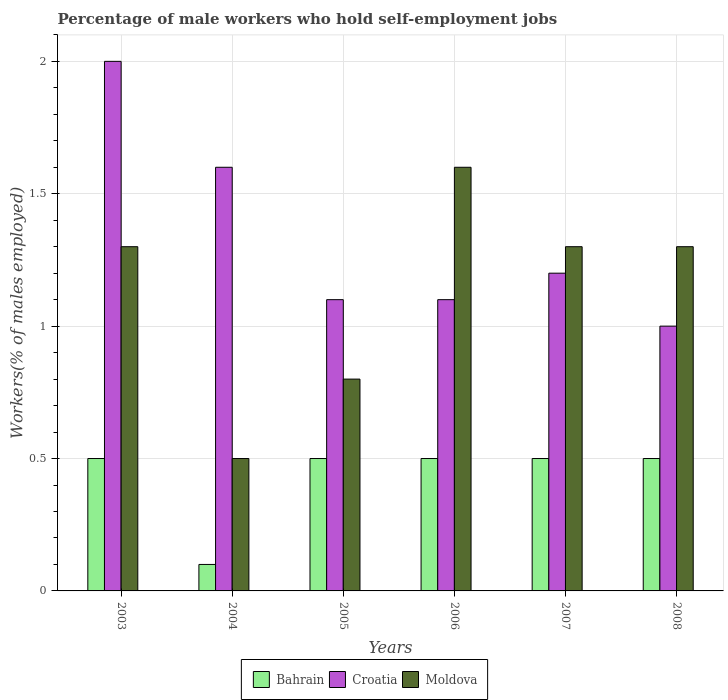How many different coloured bars are there?
Offer a very short reply. 3. How many groups of bars are there?
Offer a very short reply. 6. What is the label of the 4th group of bars from the left?
Your answer should be compact. 2006. In how many cases, is the number of bars for a given year not equal to the number of legend labels?
Keep it short and to the point. 0. What is the percentage of self-employed male workers in Croatia in 2004?
Keep it short and to the point. 1.6. Across all years, what is the maximum percentage of self-employed male workers in Moldova?
Your response must be concise. 1.6. In which year was the percentage of self-employed male workers in Bahrain maximum?
Your response must be concise. 2003. In which year was the percentage of self-employed male workers in Croatia minimum?
Make the answer very short. 2008. What is the total percentage of self-employed male workers in Moldova in the graph?
Offer a terse response. 6.8. What is the difference between the percentage of self-employed male workers in Bahrain in 2007 and the percentage of self-employed male workers in Croatia in 2006?
Provide a short and direct response. -0.6. What is the average percentage of self-employed male workers in Bahrain per year?
Provide a short and direct response. 0.43. In the year 2007, what is the difference between the percentage of self-employed male workers in Croatia and percentage of self-employed male workers in Moldova?
Your response must be concise. -0.1. In how many years, is the percentage of self-employed male workers in Bahrain greater than 0.1 %?
Give a very brief answer. 6. What is the ratio of the percentage of self-employed male workers in Moldova in 2004 to that in 2007?
Your answer should be very brief. 0.38. Is the percentage of self-employed male workers in Moldova in 2005 less than that in 2008?
Provide a succinct answer. Yes. Is the difference between the percentage of self-employed male workers in Croatia in 2004 and 2006 greater than the difference between the percentage of self-employed male workers in Moldova in 2004 and 2006?
Keep it short and to the point. Yes. What is the difference between the highest and the second highest percentage of self-employed male workers in Croatia?
Your answer should be very brief. 0.4. Is the sum of the percentage of self-employed male workers in Croatia in 2006 and 2007 greater than the maximum percentage of self-employed male workers in Moldova across all years?
Give a very brief answer. Yes. What does the 1st bar from the left in 2004 represents?
Your answer should be compact. Bahrain. What does the 1st bar from the right in 2008 represents?
Offer a terse response. Moldova. Is it the case that in every year, the sum of the percentage of self-employed male workers in Croatia and percentage of self-employed male workers in Bahrain is greater than the percentage of self-employed male workers in Moldova?
Ensure brevity in your answer.  No. How many years are there in the graph?
Provide a succinct answer. 6. Are the values on the major ticks of Y-axis written in scientific E-notation?
Ensure brevity in your answer.  No. Does the graph contain grids?
Provide a short and direct response. Yes. What is the title of the graph?
Your answer should be very brief. Percentage of male workers who hold self-employment jobs. Does "Sub-Saharan Africa (all income levels)" appear as one of the legend labels in the graph?
Your answer should be very brief. No. What is the label or title of the X-axis?
Offer a terse response. Years. What is the label or title of the Y-axis?
Your answer should be compact. Workers(% of males employed). What is the Workers(% of males employed) in Bahrain in 2003?
Offer a very short reply. 0.5. What is the Workers(% of males employed) in Croatia in 2003?
Keep it short and to the point. 2. What is the Workers(% of males employed) of Moldova in 2003?
Provide a succinct answer. 1.3. What is the Workers(% of males employed) of Bahrain in 2004?
Provide a short and direct response. 0.1. What is the Workers(% of males employed) of Croatia in 2004?
Ensure brevity in your answer.  1.6. What is the Workers(% of males employed) of Moldova in 2004?
Ensure brevity in your answer.  0.5. What is the Workers(% of males employed) in Bahrain in 2005?
Make the answer very short. 0.5. What is the Workers(% of males employed) of Croatia in 2005?
Provide a short and direct response. 1.1. What is the Workers(% of males employed) of Moldova in 2005?
Provide a succinct answer. 0.8. What is the Workers(% of males employed) of Croatia in 2006?
Your answer should be very brief. 1.1. What is the Workers(% of males employed) of Moldova in 2006?
Ensure brevity in your answer.  1.6. What is the Workers(% of males employed) of Bahrain in 2007?
Your answer should be very brief. 0.5. What is the Workers(% of males employed) in Croatia in 2007?
Provide a short and direct response. 1.2. What is the Workers(% of males employed) of Moldova in 2007?
Your answer should be compact. 1.3. What is the Workers(% of males employed) of Moldova in 2008?
Give a very brief answer. 1.3. Across all years, what is the maximum Workers(% of males employed) in Bahrain?
Your response must be concise. 0.5. Across all years, what is the maximum Workers(% of males employed) in Moldova?
Your response must be concise. 1.6. Across all years, what is the minimum Workers(% of males employed) in Bahrain?
Make the answer very short. 0.1. What is the total Workers(% of males employed) of Moldova in the graph?
Provide a short and direct response. 6.8. What is the difference between the Workers(% of males employed) in Croatia in 2003 and that in 2004?
Your answer should be very brief. 0.4. What is the difference between the Workers(% of males employed) in Moldova in 2003 and that in 2004?
Ensure brevity in your answer.  0.8. What is the difference between the Workers(% of males employed) in Bahrain in 2003 and that in 2005?
Keep it short and to the point. 0. What is the difference between the Workers(% of males employed) in Croatia in 2003 and that in 2005?
Your answer should be very brief. 0.9. What is the difference between the Workers(% of males employed) in Moldova in 2003 and that in 2005?
Your answer should be very brief. 0.5. What is the difference between the Workers(% of males employed) of Bahrain in 2003 and that in 2006?
Provide a succinct answer. 0. What is the difference between the Workers(% of males employed) in Bahrain in 2003 and that in 2007?
Provide a succinct answer. 0. What is the difference between the Workers(% of males employed) in Croatia in 2003 and that in 2007?
Make the answer very short. 0.8. What is the difference between the Workers(% of males employed) in Moldova in 2003 and that in 2007?
Your answer should be very brief. 0. What is the difference between the Workers(% of males employed) of Bahrain in 2003 and that in 2008?
Provide a succinct answer. 0. What is the difference between the Workers(% of males employed) of Bahrain in 2004 and that in 2005?
Your answer should be very brief. -0.4. What is the difference between the Workers(% of males employed) of Bahrain in 2004 and that in 2007?
Ensure brevity in your answer.  -0.4. What is the difference between the Workers(% of males employed) in Bahrain in 2004 and that in 2008?
Provide a short and direct response. -0.4. What is the difference between the Workers(% of males employed) in Moldova in 2004 and that in 2008?
Your answer should be compact. -0.8. What is the difference between the Workers(% of males employed) in Bahrain in 2005 and that in 2007?
Your response must be concise. 0. What is the difference between the Workers(% of males employed) of Bahrain in 2005 and that in 2008?
Your response must be concise. 0. What is the difference between the Workers(% of males employed) in Croatia in 2005 and that in 2008?
Your response must be concise. 0.1. What is the difference between the Workers(% of males employed) in Moldova in 2005 and that in 2008?
Offer a terse response. -0.5. What is the difference between the Workers(% of males employed) in Bahrain in 2006 and that in 2007?
Offer a terse response. 0. What is the difference between the Workers(% of males employed) in Croatia in 2006 and that in 2007?
Offer a terse response. -0.1. What is the difference between the Workers(% of males employed) of Bahrain in 2006 and that in 2008?
Make the answer very short. 0. What is the difference between the Workers(% of males employed) in Croatia in 2006 and that in 2008?
Give a very brief answer. 0.1. What is the difference between the Workers(% of males employed) in Bahrain in 2007 and that in 2008?
Keep it short and to the point. 0. What is the difference between the Workers(% of males employed) in Croatia in 2007 and that in 2008?
Keep it short and to the point. 0.2. What is the difference between the Workers(% of males employed) in Bahrain in 2003 and the Workers(% of males employed) in Moldova in 2004?
Your answer should be very brief. 0. What is the difference between the Workers(% of males employed) of Croatia in 2003 and the Workers(% of males employed) of Moldova in 2004?
Provide a succinct answer. 1.5. What is the difference between the Workers(% of males employed) of Bahrain in 2003 and the Workers(% of males employed) of Moldova in 2006?
Your answer should be very brief. -1.1. What is the difference between the Workers(% of males employed) of Croatia in 2003 and the Workers(% of males employed) of Moldova in 2006?
Provide a succinct answer. 0.4. What is the difference between the Workers(% of males employed) in Bahrain in 2003 and the Workers(% of males employed) in Moldova in 2007?
Your answer should be compact. -0.8. What is the difference between the Workers(% of males employed) of Bahrain in 2003 and the Workers(% of males employed) of Moldova in 2008?
Provide a short and direct response. -0.8. What is the difference between the Workers(% of males employed) in Croatia in 2003 and the Workers(% of males employed) in Moldova in 2008?
Offer a very short reply. 0.7. What is the difference between the Workers(% of males employed) of Bahrain in 2004 and the Workers(% of males employed) of Croatia in 2005?
Offer a terse response. -1. What is the difference between the Workers(% of males employed) of Croatia in 2004 and the Workers(% of males employed) of Moldova in 2005?
Your answer should be very brief. 0.8. What is the difference between the Workers(% of males employed) in Bahrain in 2004 and the Workers(% of males employed) in Croatia in 2006?
Offer a very short reply. -1. What is the difference between the Workers(% of males employed) of Croatia in 2004 and the Workers(% of males employed) of Moldova in 2006?
Give a very brief answer. 0. What is the difference between the Workers(% of males employed) in Bahrain in 2004 and the Workers(% of males employed) in Croatia in 2007?
Your response must be concise. -1.1. What is the difference between the Workers(% of males employed) of Croatia in 2005 and the Workers(% of males employed) of Moldova in 2006?
Your response must be concise. -0.5. What is the difference between the Workers(% of males employed) of Bahrain in 2005 and the Workers(% of males employed) of Croatia in 2007?
Provide a short and direct response. -0.7. What is the difference between the Workers(% of males employed) of Croatia in 2005 and the Workers(% of males employed) of Moldova in 2007?
Offer a terse response. -0.2. What is the difference between the Workers(% of males employed) of Bahrain in 2005 and the Workers(% of males employed) of Moldova in 2008?
Your answer should be very brief. -0.8. What is the difference between the Workers(% of males employed) in Croatia in 2005 and the Workers(% of males employed) in Moldova in 2008?
Offer a very short reply. -0.2. What is the difference between the Workers(% of males employed) of Bahrain in 2006 and the Workers(% of males employed) of Moldova in 2007?
Give a very brief answer. -0.8. What is the difference between the Workers(% of males employed) of Croatia in 2006 and the Workers(% of males employed) of Moldova in 2007?
Give a very brief answer. -0.2. What is the difference between the Workers(% of males employed) in Bahrain in 2006 and the Workers(% of males employed) in Moldova in 2008?
Your answer should be very brief. -0.8. What is the difference between the Workers(% of males employed) of Bahrain in 2007 and the Workers(% of males employed) of Moldova in 2008?
Ensure brevity in your answer.  -0.8. What is the difference between the Workers(% of males employed) of Croatia in 2007 and the Workers(% of males employed) of Moldova in 2008?
Provide a succinct answer. -0.1. What is the average Workers(% of males employed) of Bahrain per year?
Give a very brief answer. 0.43. What is the average Workers(% of males employed) in Croatia per year?
Offer a terse response. 1.33. What is the average Workers(% of males employed) of Moldova per year?
Ensure brevity in your answer.  1.13. In the year 2003, what is the difference between the Workers(% of males employed) in Bahrain and Workers(% of males employed) in Moldova?
Provide a succinct answer. -0.8. In the year 2003, what is the difference between the Workers(% of males employed) of Croatia and Workers(% of males employed) of Moldova?
Your answer should be very brief. 0.7. In the year 2004, what is the difference between the Workers(% of males employed) in Bahrain and Workers(% of males employed) in Moldova?
Offer a terse response. -0.4. In the year 2004, what is the difference between the Workers(% of males employed) of Croatia and Workers(% of males employed) of Moldova?
Your answer should be compact. 1.1. In the year 2005, what is the difference between the Workers(% of males employed) of Bahrain and Workers(% of males employed) of Croatia?
Your answer should be compact. -0.6. In the year 2005, what is the difference between the Workers(% of males employed) in Croatia and Workers(% of males employed) in Moldova?
Your answer should be very brief. 0.3. In the year 2006, what is the difference between the Workers(% of males employed) in Bahrain and Workers(% of males employed) in Croatia?
Offer a terse response. -0.6. In the year 2006, what is the difference between the Workers(% of males employed) in Bahrain and Workers(% of males employed) in Moldova?
Ensure brevity in your answer.  -1.1. In the year 2007, what is the difference between the Workers(% of males employed) in Croatia and Workers(% of males employed) in Moldova?
Offer a very short reply. -0.1. In the year 2008, what is the difference between the Workers(% of males employed) of Bahrain and Workers(% of males employed) of Croatia?
Your answer should be very brief. -0.5. What is the ratio of the Workers(% of males employed) of Bahrain in 2003 to that in 2004?
Keep it short and to the point. 5. What is the ratio of the Workers(% of males employed) of Bahrain in 2003 to that in 2005?
Provide a short and direct response. 1. What is the ratio of the Workers(% of males employed) of Croatia in 2003 to that in 2005?
Give a very brief answer. 1.82. What is the ratio of the Workers(% of males employed) in Moldova in 2003 to that in 2005?
Provide a succinct answer. 1.62. What is the ratio of the Workers(% of males employed) of Croatia in 2003 to that in 2006?
Make the answer very short. 1.82. What is the ratio of the Workers(% of males employed) in Moldova in 2003 to that in 2006?
Provide a succinct answer. 0.81. What is the ratio of the Workers(% of males employed) in Bahrain in 2003 to that in 2007?
Offer a very short reply. 1. What is the ratio of the Workers(% of males employed) of Croatia in 2003 to that in 2007?
Ensure brevity in your answer.  1.67. What is the ratio of the Workers(% of males employed) in Moldova in 2003 to that in 2008?
Give a very brief answer. 1. What is the ratio of the Workers(% of males employed) of Croatia in 2004 to that in 2005?
Offer a very short reply. 1.45. What is the ratio of the Workers(% of males employed) of Moldova in 2004 to that in 2005?
Make the answer very short. 0.62. What is the ratio of the Workers(% of males employed) of Bahrain in 2004 to that in 2006?
Your answer should be compact. 0.2. What is the ratio of the Workers(% of males employed) in Croatia in 2004 to that in 2006?
Provide a succinct answer. 1.45. What is the ratio of the Workers(% of males employed) of Moldova in 2004 to that in 2006?
Your response must be concise. 0.31. What is the ratio of the Workers(% of males employed) of Bahrain in 2004 to that in 2007?
Offer a very short reply. 0.2. What is the ratio of the Workers(% of males employed) of Moldova in 2004 to that in 2007?
Your answer should be compact. 0.38. What is the ratio of the Workers(% of males employed) of Croatia in 2004 to that in 2008?
Provide a short and direct response. 1.6. What is the ratio of the Workers(% of males employed) of Moldova in 2004 to that in 2008?
Give a very brief answer. 0.38. What is the ratio of the Workers(% of males employed) of Croatia in 2005 to that in 2006?
Ensure brevity in your answer.  1. What is the ratio of the Workers(% of males employed) of Moldova in 2005 to that in 2007?
Keep it short and to the point. 0.62. What is the ratio of the Workers(% of males employed) in Bahrain in 2005 to that in 2008?
Give a very brief answer. 1. What is the ratio of the Workers(% of males employed) of Croatia in 2005 to that in 2008?
Give a very brief answer. 1.1. What is the ratio of the Workers(% of males employed) of Moldova in 2005 to that in 2008?
Your response must be concise. 0.62. What is the ratio of the Workers(% of males employed) of Bahrain in 2006 to that in 2007?
Offer a terse response. 1. What is the ratio of the Workers(% of males employed) in Croatia in 2006 to that in 2007?
Give a very brief answer. 0.92. What is the ratio of the Workers(% of males employed) of Moldova in 2006 to that in 2007?
Your answer should be compact. 1.23. What is the ratio of the Workers(% of males employed) in Croatia in 2006 to that in 2008?
Provide a short and direct response. 1.1. What is the ratio of the Workers(% of males employed) in Moldova in 2006 to that in 2008?
Offer a very short reply. 1.23. What is the difference between the highest and the second highest Workers(% of males employed) of Bahrain?
Provide a short and direct response. 0. What is the difference between the highest and the lowest Workers(% of males employed) of Croatia?
Your answer should be very brief. 1. What is the difference between the highest and the lowest Workers(% of males employed) in Moldova?
Provide a succinct answer. 1.1. 